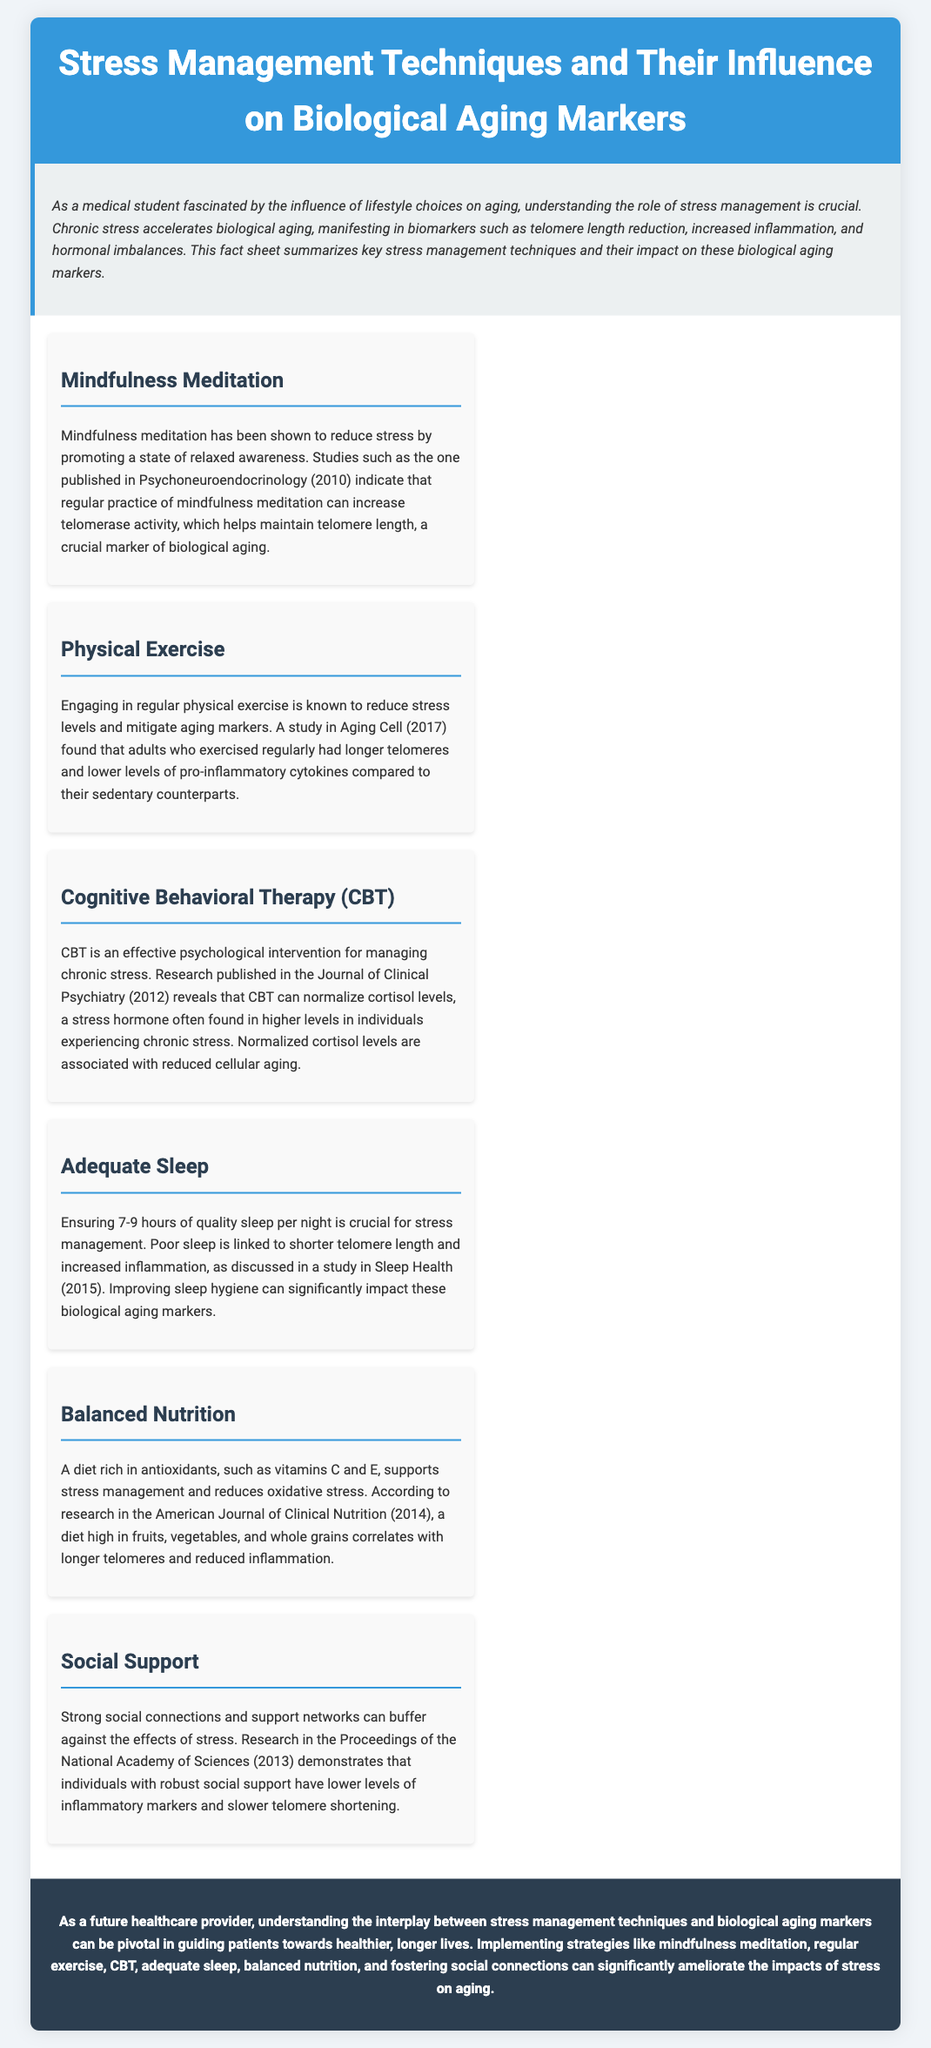What is the main subject of the document? The document discusses stress management techniques and their effects on biological aging markers.
Answer: Stress management techniques and biological aging markers What is the purpose of mindfulness meditation according to the document? Mindfulness meditation is promoted for reducing stress and increasing telomerase activity.
Answer: Reducing stress and increasing telomerase activity How many hours of sleep are recommended for adequate sleep? The document states that 7-9 hours of quality sleep is crucial for stress management.
Answer: 7-9 hours Which nutrient is mentioned as important for balancing nutrition? The document highlights antioxidants, specifically vitamins C and E, as important nutrients.
Answer: Antioxidants, vitamins C and E What is the study that discusses physical exercise's impact on biological aging? The study referred to is published in Aging Cell in 2017, indicating exercise leads to longer telomeres.
Answer: Aging Cell (2017) What psychological intervention is identified for managing chronic stress? Cognitive Behavioral Therapy (CBT) is identified as the intervention for managing chronic stress.
Answer: Cognitive Behavioral Therapy (CBT) What are lower levels of inflammatory markers associated with? Strong social connections are associated with lower levels of inflammatory markers.
Answer: Strong social connections What does normalized cortisol levels relate to according to the document? Normalized cortisol levels are linked to reduced cellular aging.
Answer: Reduced cellular aging 